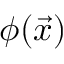Convert formula to latex. <formula><loc_0><loc_0><loc_500><loc_500>\phi ( \vec { x } )</formula> 